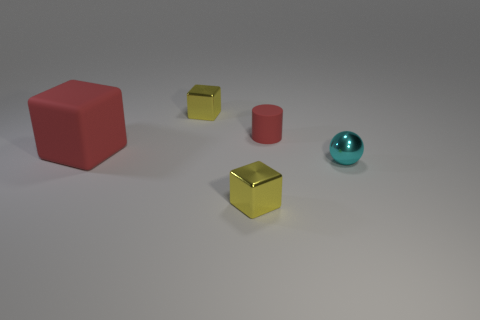Add 1 gray metal cylinders. How many objects exist? 6 Subtract all cubes. How many objects are left? 2 Add 5 big yellow rubber cubes. How many big yellow rubber cubes exist? 5 Subtract 0 yellow cylinders. How many objects are left? 5 Subtract all spheres. Subtract all red blocks. How many objects are left? 3 Add 5 matte cylinders. How many matte cylinders are left? 6 